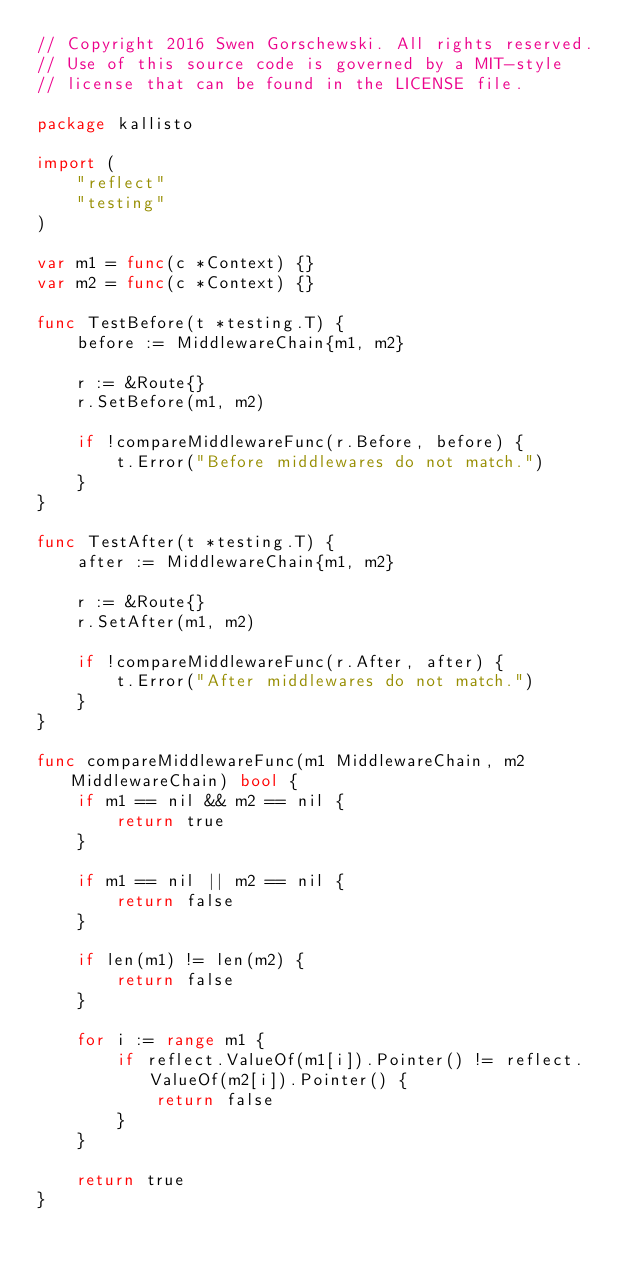<code> <loc_0><loc_0><loc_500><loc_500><_Go_>// Copyright 2016 Swen Gorschewski. All rights reserved.
// Use of this source code is governed by a MIT-style
// license that can be found in the LICENSE file.

package kallisto

import (
	"reflect"
	"testing"
)

var m1 = func(c *Context) {}
var m2 = func(c *Context) {}

func TestBefore(t *testing.T) {
	before := MiddlewareChain{m1, m2}

	r := &Route{}
	r.SetBefore(m1, m2)

	if !compareMiddlewareFunc(r.Before, before) {
		t.Error("Before middlewares do not match.")
	}
}

func TestAfter(t *testing.T) {
	after := MiddlewareChain{m1, m2}

	r := &Route{}
	r.SetAfter(m1, m2)

	if !compareMiddlewareFunc(r.After, after) {
		t.Error("After middlewares do not match.")
	}
}

func compareMiddlewareFunc(m1 MiddlewareChain, m2 MiddlewareChain) bool {
	if m1 == nil && m2 == nil {
		return true
	}

	if m1 == nil || m2 == nil {
		return false
	}

	if len(m1) != len(m2) {
		return false
	}

	for i := range m1 {
		if reflect.ValueOf(m1[i]).Pointer() != reflect.ValueOf(m2[i]).Pointer() {
			return false
		}
	}

	return true
}
</code> 